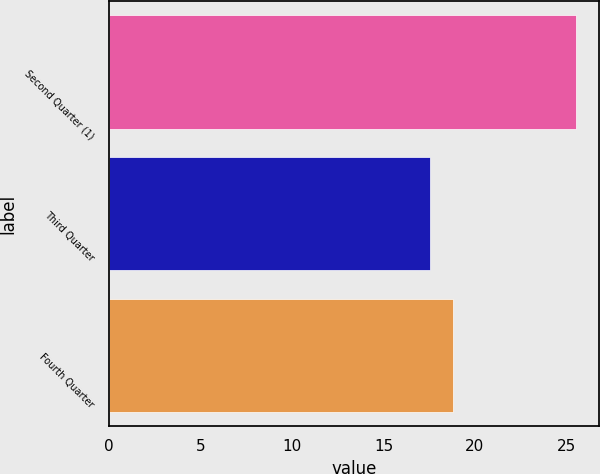Convert chart to OTSL. <chart><loc_0><loc_0><loc_500><loc_500><bar_chart><fcel>Second Quarter (1)<fcel>Third Quarter<fcel>Fourth Quarter<nl><fcel>25.52<fcel>17.55<fcel>18.8<nl></chart> 